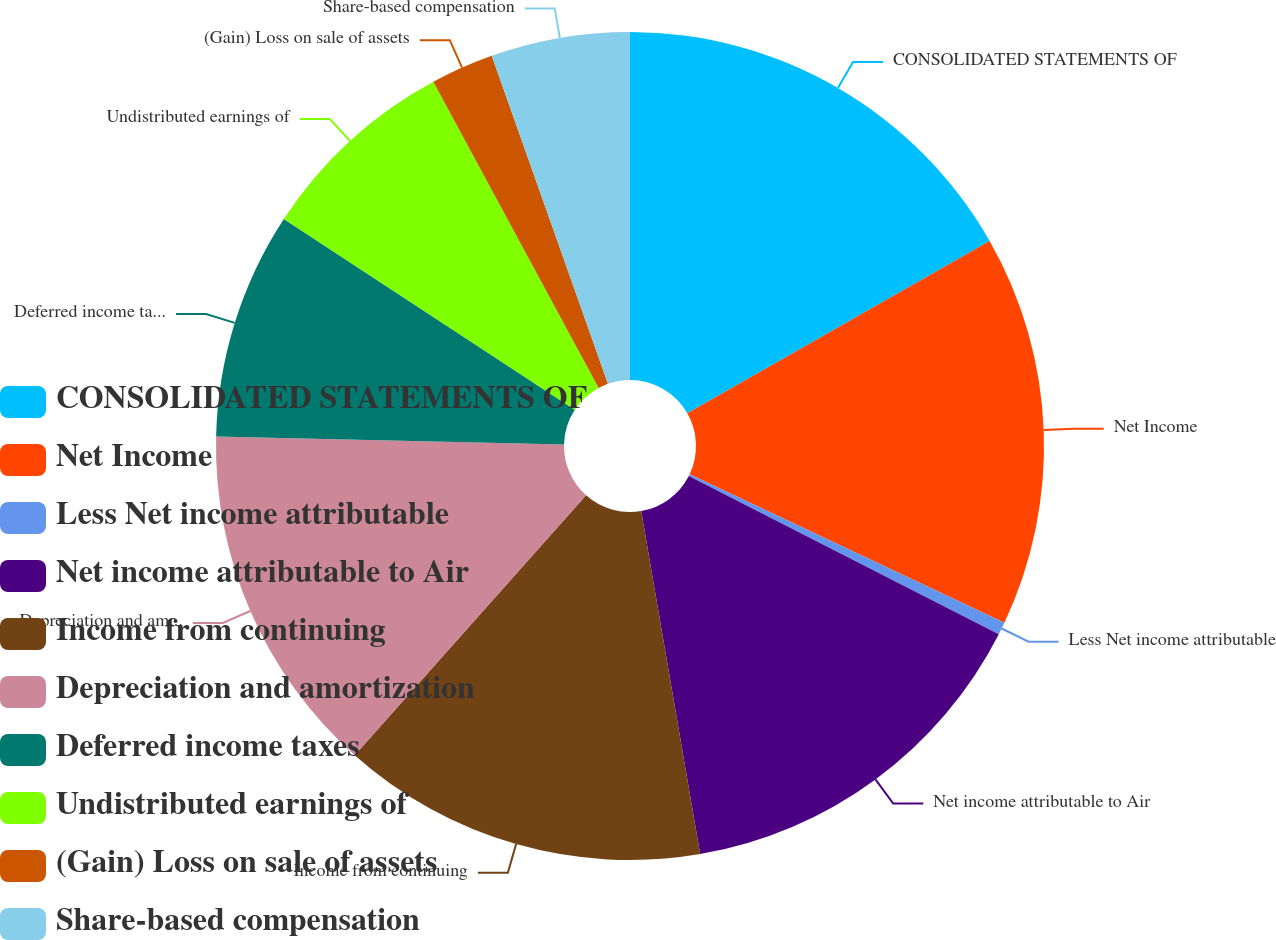Convert chart to OTSL. <chart><loc_0><loc_0><loc_500><loc_500><pie_chart><fcel>CONSOLIDATED STATEMENTS OF<fcel>Net Income<fcel>Less Net income attributable<fcel>Net income attributable to Air<fcel>Income from continuing<fcel>Depreciation and amortization<fcel>Deferred income taxes<fcel>Undistributed earnings of<fcel>(Gain) Loss on sale of assets<fcel>Share-based compensation<nl><fcel>16.75%<fcel>15.27%<fcel>0.49%<fcel>14.78%<fcel>14.29%<fcel>13.79%<fcel>8.87%<fcel>7.88%<fcel>2.46%<fcel>5.42%<nl></chart> 